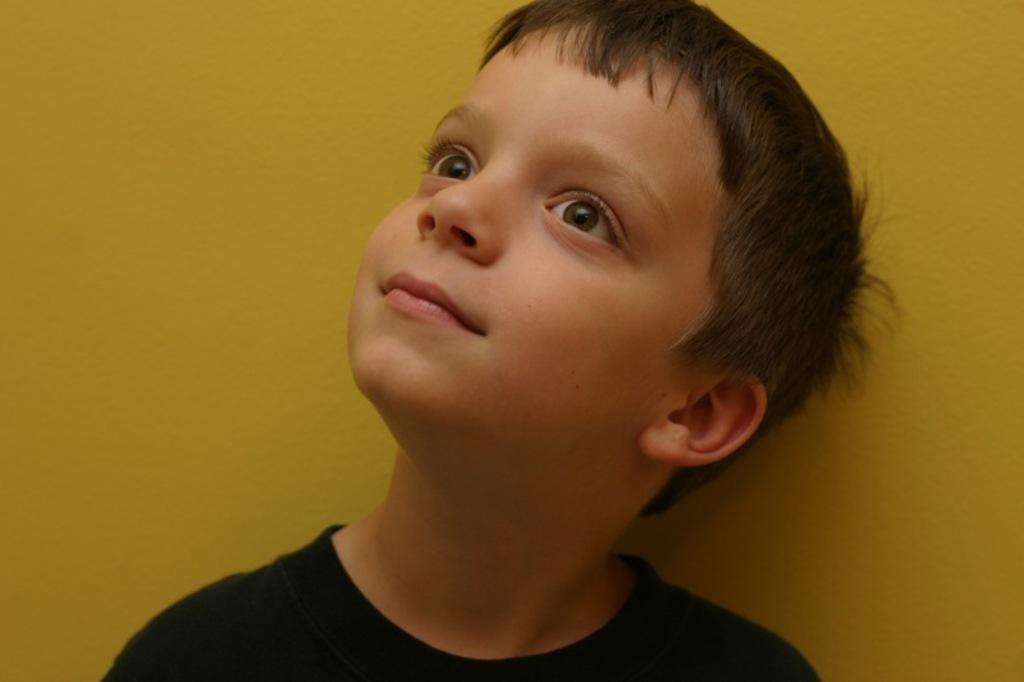Who is in the image? There is a boy in the image. What is the boy doing in the image? The boy is smiling in the image. What is the boy wearing in the image? The boy is wearing a black t-shirt in the image. What can be seen in the background of the image? There is a yellow color wall in the background of the image. How many bulbs are hanging from the ceiling in the image? There are no bulbs visible in the image; it only shows a boy smiling in front of a yellow color wall. 